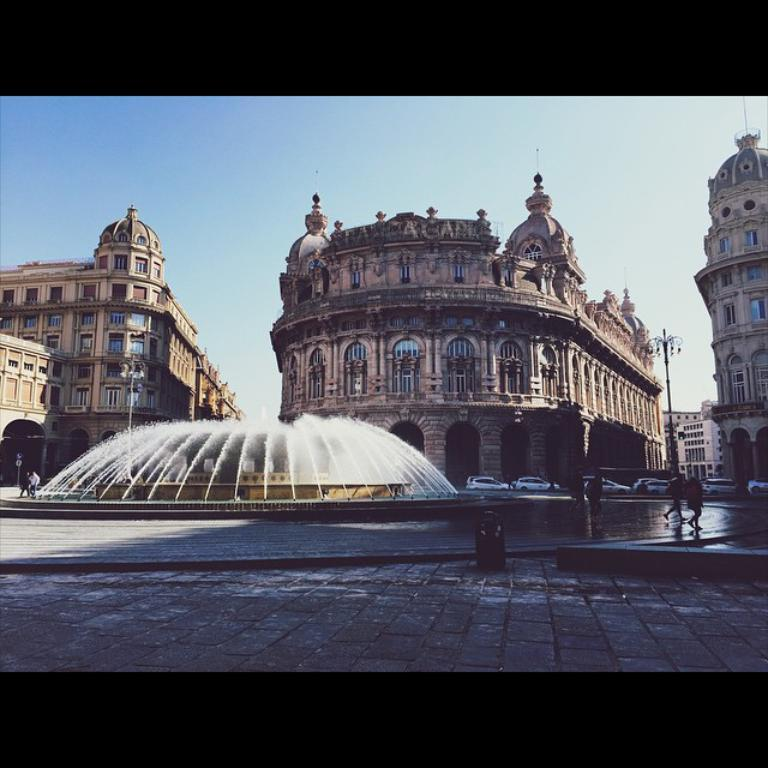What type of structures can be seen in the image? There are buildings in the image. What type of vehicles are present in the image? There are cars in the image. What type of water feature is visible in the image? There is a fountain in the image. What is the surface beneath the cars and buildings in the image? The bottom of the image contains a floor. What is visible at the top of the image? The top of the image contains the sky. Can you see any goldfish swimming in the fountain in the image? There are no goldfish visible in the fountain in the image. What type of control panel is present in the image to operate the buildings and cars? There is no control panel present in the image; it is a static representation of the scene. 